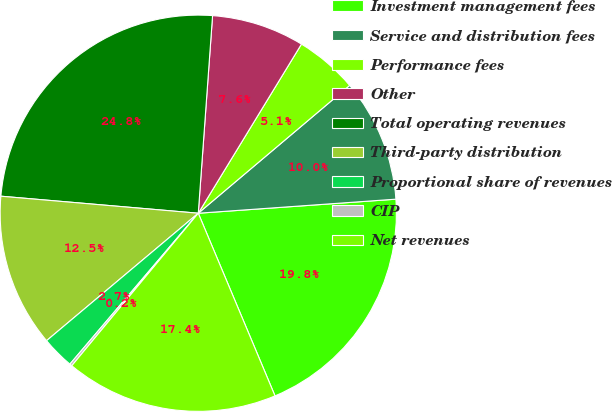<chart> <loc_0><loc_0><loc_500><loc_500><pie_chart><fcel>Investment management fees<fcel>Service and distribution fees<fcel>Performance fees<fcel>Other<fcel>Total operating revenues<fcel>Third-party distribution<fcel>Proportional share of revenues<fcel>CIP<fcel>Net revenues<nl><fcel>19.8%<fcel>10.03%<fcel>5.12%<fcel>7.57%<fcel>24.78%<fcel>12.49%<fcel>2.66%<fcel>0.2%<fcel>17.35%<nl></chart> 